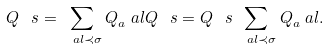<formula> <loc_0><loc_0><loc_500><loc_500>Q ^ { \ } s = \sum _ { \ a l \prec \sigma } Q _ { a } ^ { \ } a l Q ^ { \ } s = Q ^ { \ } s \sum _ { \ a l \prec \sigma } Q _ { a } ^ { \ } a l .</formula> 